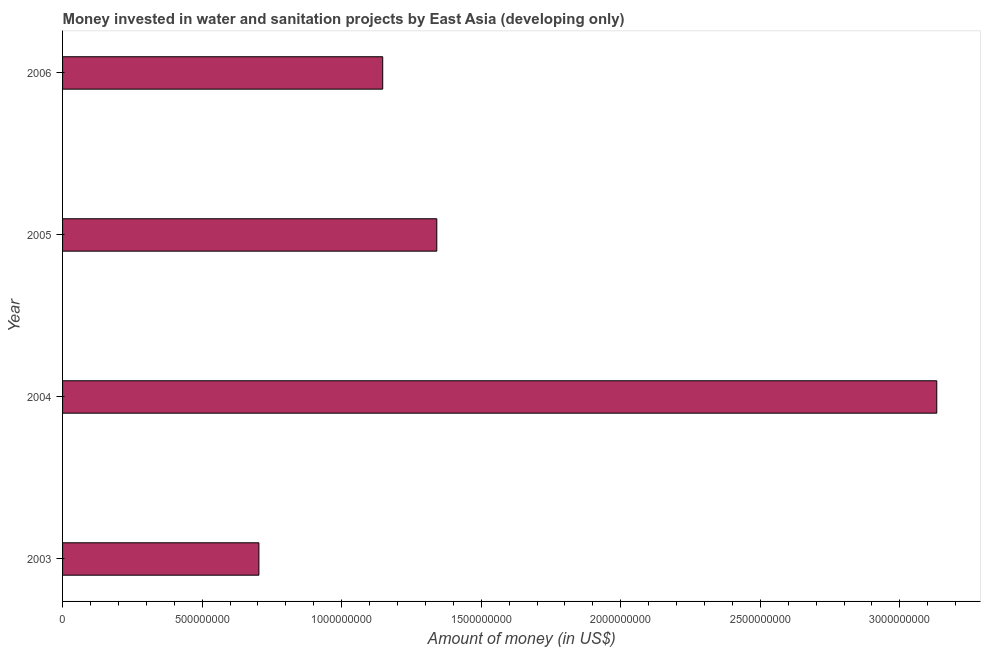Does the graph contain any zero values?
Offer a terse response. No. Does the graph contain grids?
Your answer should be compact. No. What is the title of the graph?
Offer a terse response. Money invested in water and sanitation projects by East Asia (developing only). What is the label or title of the X-axis?
Keep it short and to the point. Amount of money (in US$). What is the investment in 2004?
Your answer should be very brief. 3.13e+09. Across all years, what is the maximum investment?
Give a very brief answer. 3.13e+09. Across all years, what is the minimum investment?
Your answer should be compact. 7.04e+08. In which year was the investment minimum?
Give a very brief answer. 2003. What is the sum of the investment?
Make the answer very short. 6.32e+09. What is the difference between the investment in 2005 and 2006?
Make the answer very short. 1.94e+08. What is the average investment per year?
Make the answer very short. 1.58e+09. What is the median investment?
Your response must be concise. 1.24e+09. What is the ratio of the investment in 2003 to that in 2004?
Your answer should be very brief. 0.23. Is the investment in 2003 less than that in 2004?
Give a very brief answer. Yes. What is the difference between the highest and the second highest investment?
Ensure brevity in your answer.  1.79e+09. Is the sum of the investment in 2003 and 2004 greater than the maximum investment across all years?
Offer a terse response. Yes. What is the difference between the highest and the lowest investment?
Offer a terse response. 2.43e+09. In how many years, is the investment greater than the average investment taken over all years?
Provide a succinct answer. 1. Are all the bars in the graph horizontal?
Your answer should be compact. Yes. Are the values on the major ticks of X-axis written in scientific E-notation?
Provide a succinct answer. No. What is the Amount of money (in US$) in 2003?
Provide a succinct answer. 7.04e+08. What is the Amount of money (in US$) in 2004?
Your answer should be very brief. 3.13e+09. What is the Amount of money (in US$) of 2005?
Make the answer very short. 1.34e+09. What is the Amount of money (in US$) of 2006?
Your answer should be compact. 1.15e+09. What is the difference between the Amount of money (in US$) in 2003 and 2004?
Keep it short and to the point. -2.43e+09. What is the difference between the Amount of money (in US$) in 2003 and 2005?
Provide a succinct answer. -6.37e+08. What is the difference between the Amount of money (in US$) in 2003 and 2006?
Ensure brevity in your answer.  -4.44e+08. What is the difference between the Amount of money (in US$) in 2004 and 2005?
Ensure brevity in your answer.  1.79e+09. What is the difference between the Amount of money (in US$) in 2004 and 2006?
Provide a short and direct response. 1.99e+09. What is the difference between the Amount of money (in US$) in 2005 and 2006?
Keep it short and to the point. 1.94e+08. What is the ratio of the Amount of money (in US$) in 2003 to that in 2004?
Offer a very short reply. 0.23. What is the ratio of the Amount of money (in US$) in 2003 to that in 2005?
Provide a short and direct response. 0.53. What is the ratio of the Amount of money (in US$) in 2003 to that in 2006?
Your response must be concise. 0.61. What is the ratio of the Amount of money (in US$) in 2004 to that in 2005?
Offer a very short reply. 2.34. What is the ratio of the Amount of money (in US$) in 2004 to that in 2006?
Provide a succinct answer. 2.73. What is the ratio of the Amount of money (in US$) in 2005 to that in 2006?
Make the answer very short. 1.17. 